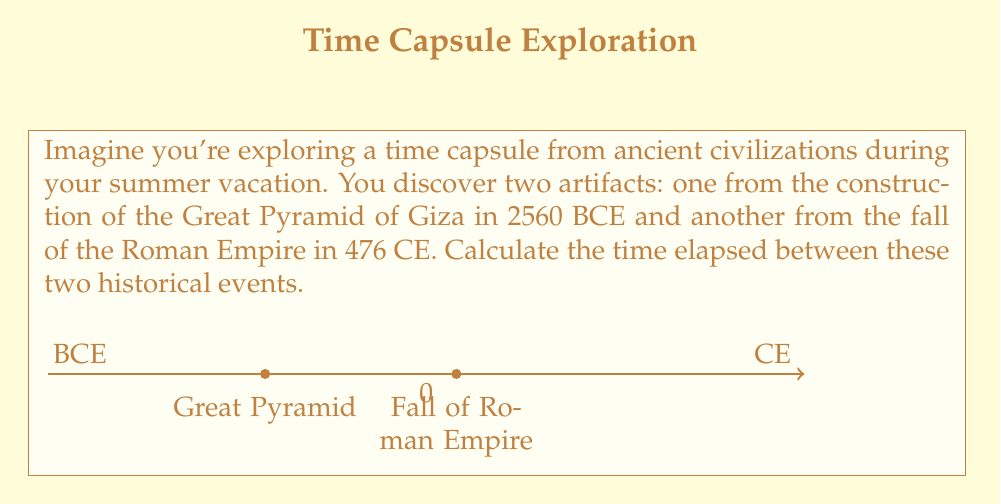Solve this math problem. Let's approach this step-by-step:

1) First, we need to understand that BCE (Before Common Era) years are represented as negative numbers on a timeline, while CE (Common Era) years are positive.

2) The Great Pyramid was built in 2560 BCE, so we represent this as $-2560$ on our number line.

3) The fall of the Roman Empire occurred in 476 CE, which is simply $476$ on our number line.

4) To find the elapsed time, we need to calculate the distance between these two points on the number line. We can do this by subtracting the earlier date from the later date:

   $$ 476 - (-2560) $$

5) Remember, subtracting a negative is the same as adding its positive:

   $$ 476 + 2560 = 3036 $$

6) Therefore, the elapsed time between the construction of the Great Pyramid and the fall of the Roman Empire is 3036 years.
Answer: 3036 years 